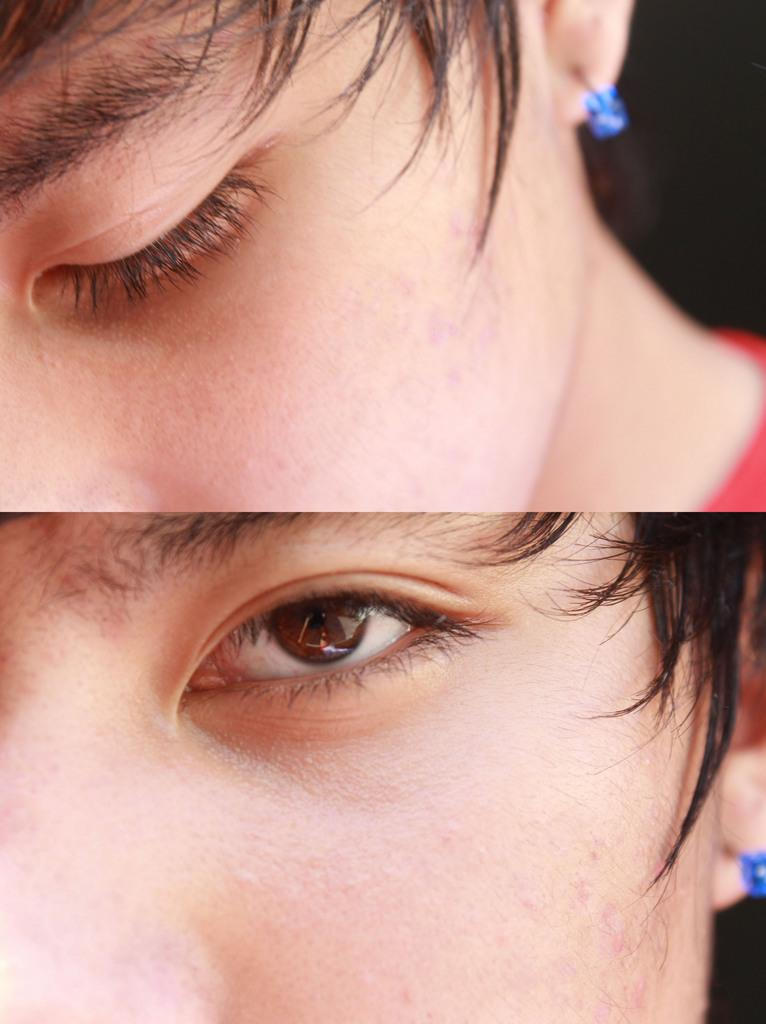What is happening in the first image? In the first image, the person is closing his eye. What is happening in the second image? In the second image, the person is opening his eye. Can you describe the person's action in both images? In the first image, the person is closing his eye, and in the second image, he is opening his eye. What type of knife is the person holding in the image? There is no knife present in the image; the person is simply closing and opening his eye. How many horses are visible in the image? There are no horses present in the image; it only features a person closing and opening his eye. 